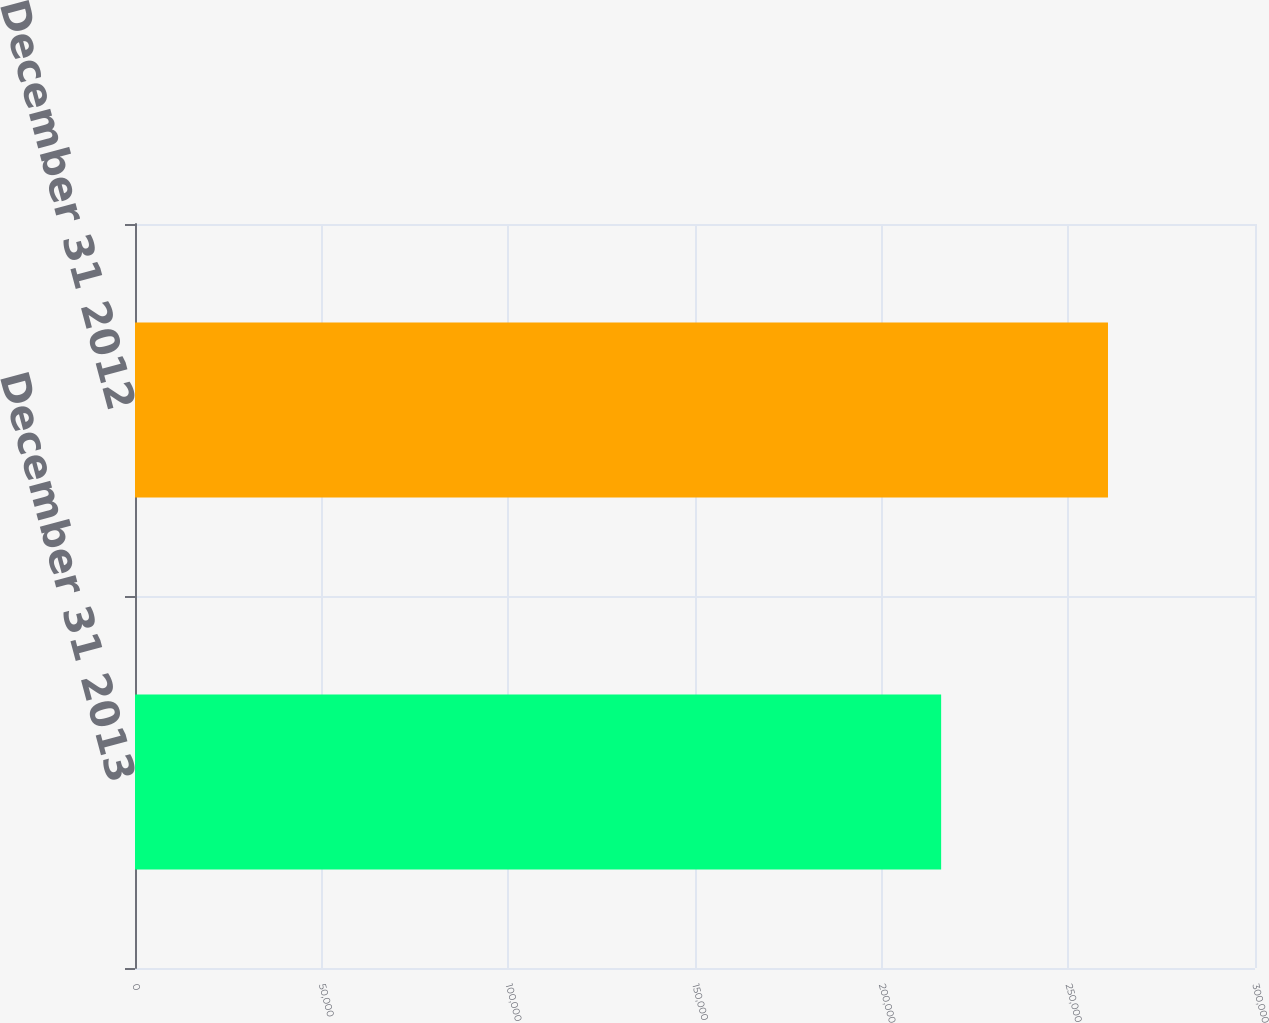<chart> <loc_0><loc_0><loc_500><loc_500><bar_chart><fcel>December 31 2013<fcel>December 31 2012<nl><fcel>215930<fcel>260622<nl></chart> 